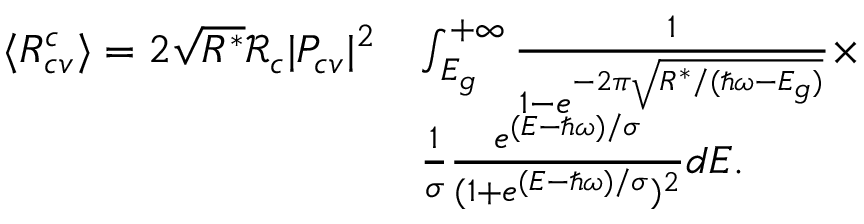<formula> <loc_0><loc_0><loc_500><loc_500>\begin{array} { r l } { \langle R _ { c v } ^ { c } \rangle = 2 \sqrt { R ^ { * } } \mathcal { R } _ { c } | P _ { c v } | ^ { 2 } } & { \int _ { E _ { g } } ^ { + \infty } \frac { 1 } { 1 - e ^ { - 2 \pi \sqrt { R ^ { * } / ( \hbar { \omega } - E _ { g } ) } } } \times } \\ & { \frac { 1 } { \sigma } \frac { e ^ { ( E - \hbar { \omega } ) / \sigma } } { ( 1 + e ^ { ( E - \hbar { \omega } ) / \sigma } ) ^ { 2 } } d E . } \end{array}</formula> 